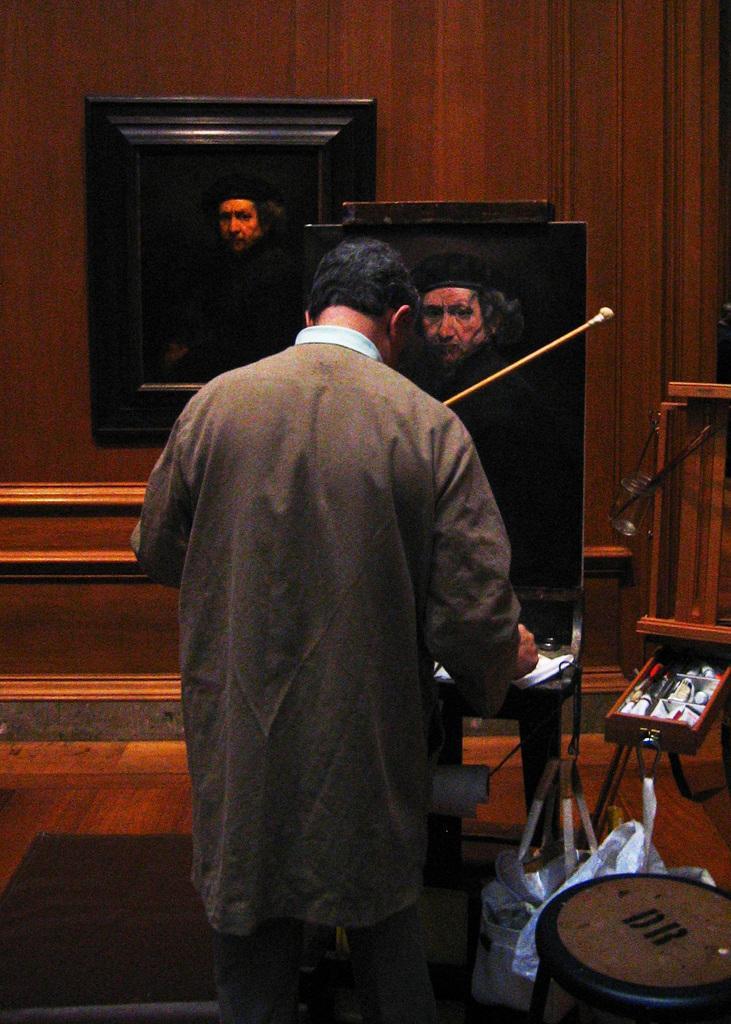Please provide a concise description of this image. In this image we can see a person is standing and at the board and on the right side we can see a stool, bags and other objects. In the background we can see a frame on the wall. 